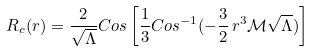<formula> <loc_0><loc_0><loc_500><loc_500>R _ { c } ( r ) = \frac { 2 } { \sqrt { \Lambda } } C o s \left [ \frac { 1 } { 3 } C o s ^ { - 1 } ( - \frac { 3 } { 2 } \, r ^ { 3 } \mathcal { M } \sqrt { \Lambda } ) \right ]</formula> 